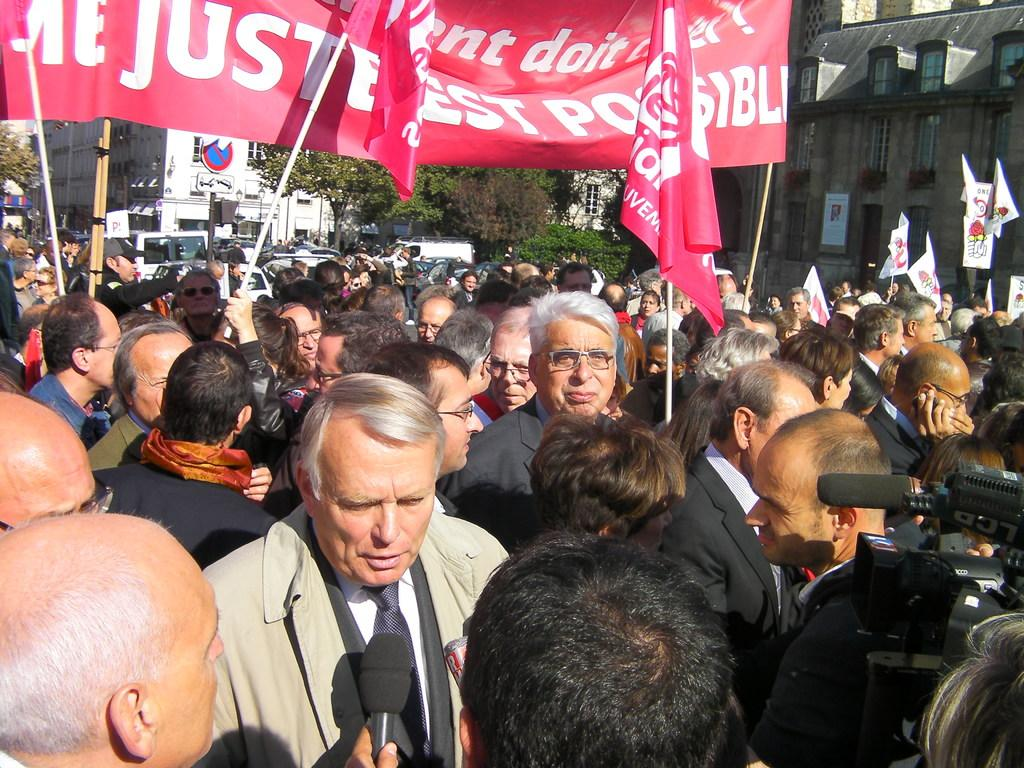What can be seen in the image? There are people, banners, and a microphone in the image. What is visible in the background of the image? There are buildings, trees, a board on a pole, and vehicles in the background of the image. What might be used for amplifying sound in the image? The microphone in the image might be used for amplifying sound. What type of lock is holding the banners in the image? There is no lock present in the image; the banners are not held by a lock. How does the grandfather contribute to the scene in the image? There is no mention of a grandfather in the image, so it is not possible to determine his contribution to the scene. 